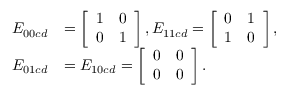Convert formula to latex. <formula><loc_0><loc_0><loc_500><loc_500>\begin{array} { r l } { E _ { 0 0 c d } } & { = \left [ \begin{array} { l l } { 1 } & { 0 } \\ { 0 } & { 1 } \end{array} \right ] , E _ { 1 1 c d } = \left [ \begin{array} { l l } { 0 } & { 1 } \\ { 1 } & { 0 } \end{array} \right ] , } \\ { E _ { 0 1 c d } } & { = E _ { 1 0 c d } = \left [ \begin{array} { l l } { 0 } & { 0 } \\ { 0 } & { 0 } \end{array} \right ] . } \end{array}</formula> 